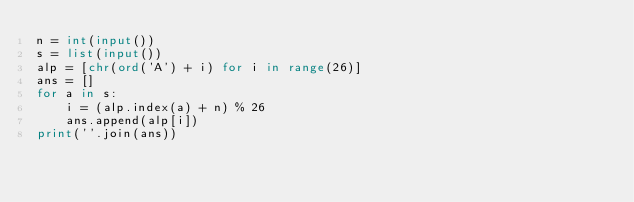<code> <loc_0><loc_0><loc_500><loc_500><_Python_>n = int(input())
s = list(input())
alp = [chr(ord('A') + i) for i in range(26)]
ans = []
for a in s:
    i = (alp.index(a) + n) % 26
    ans.append(alp[i])
print(''.join(ans))</code> 